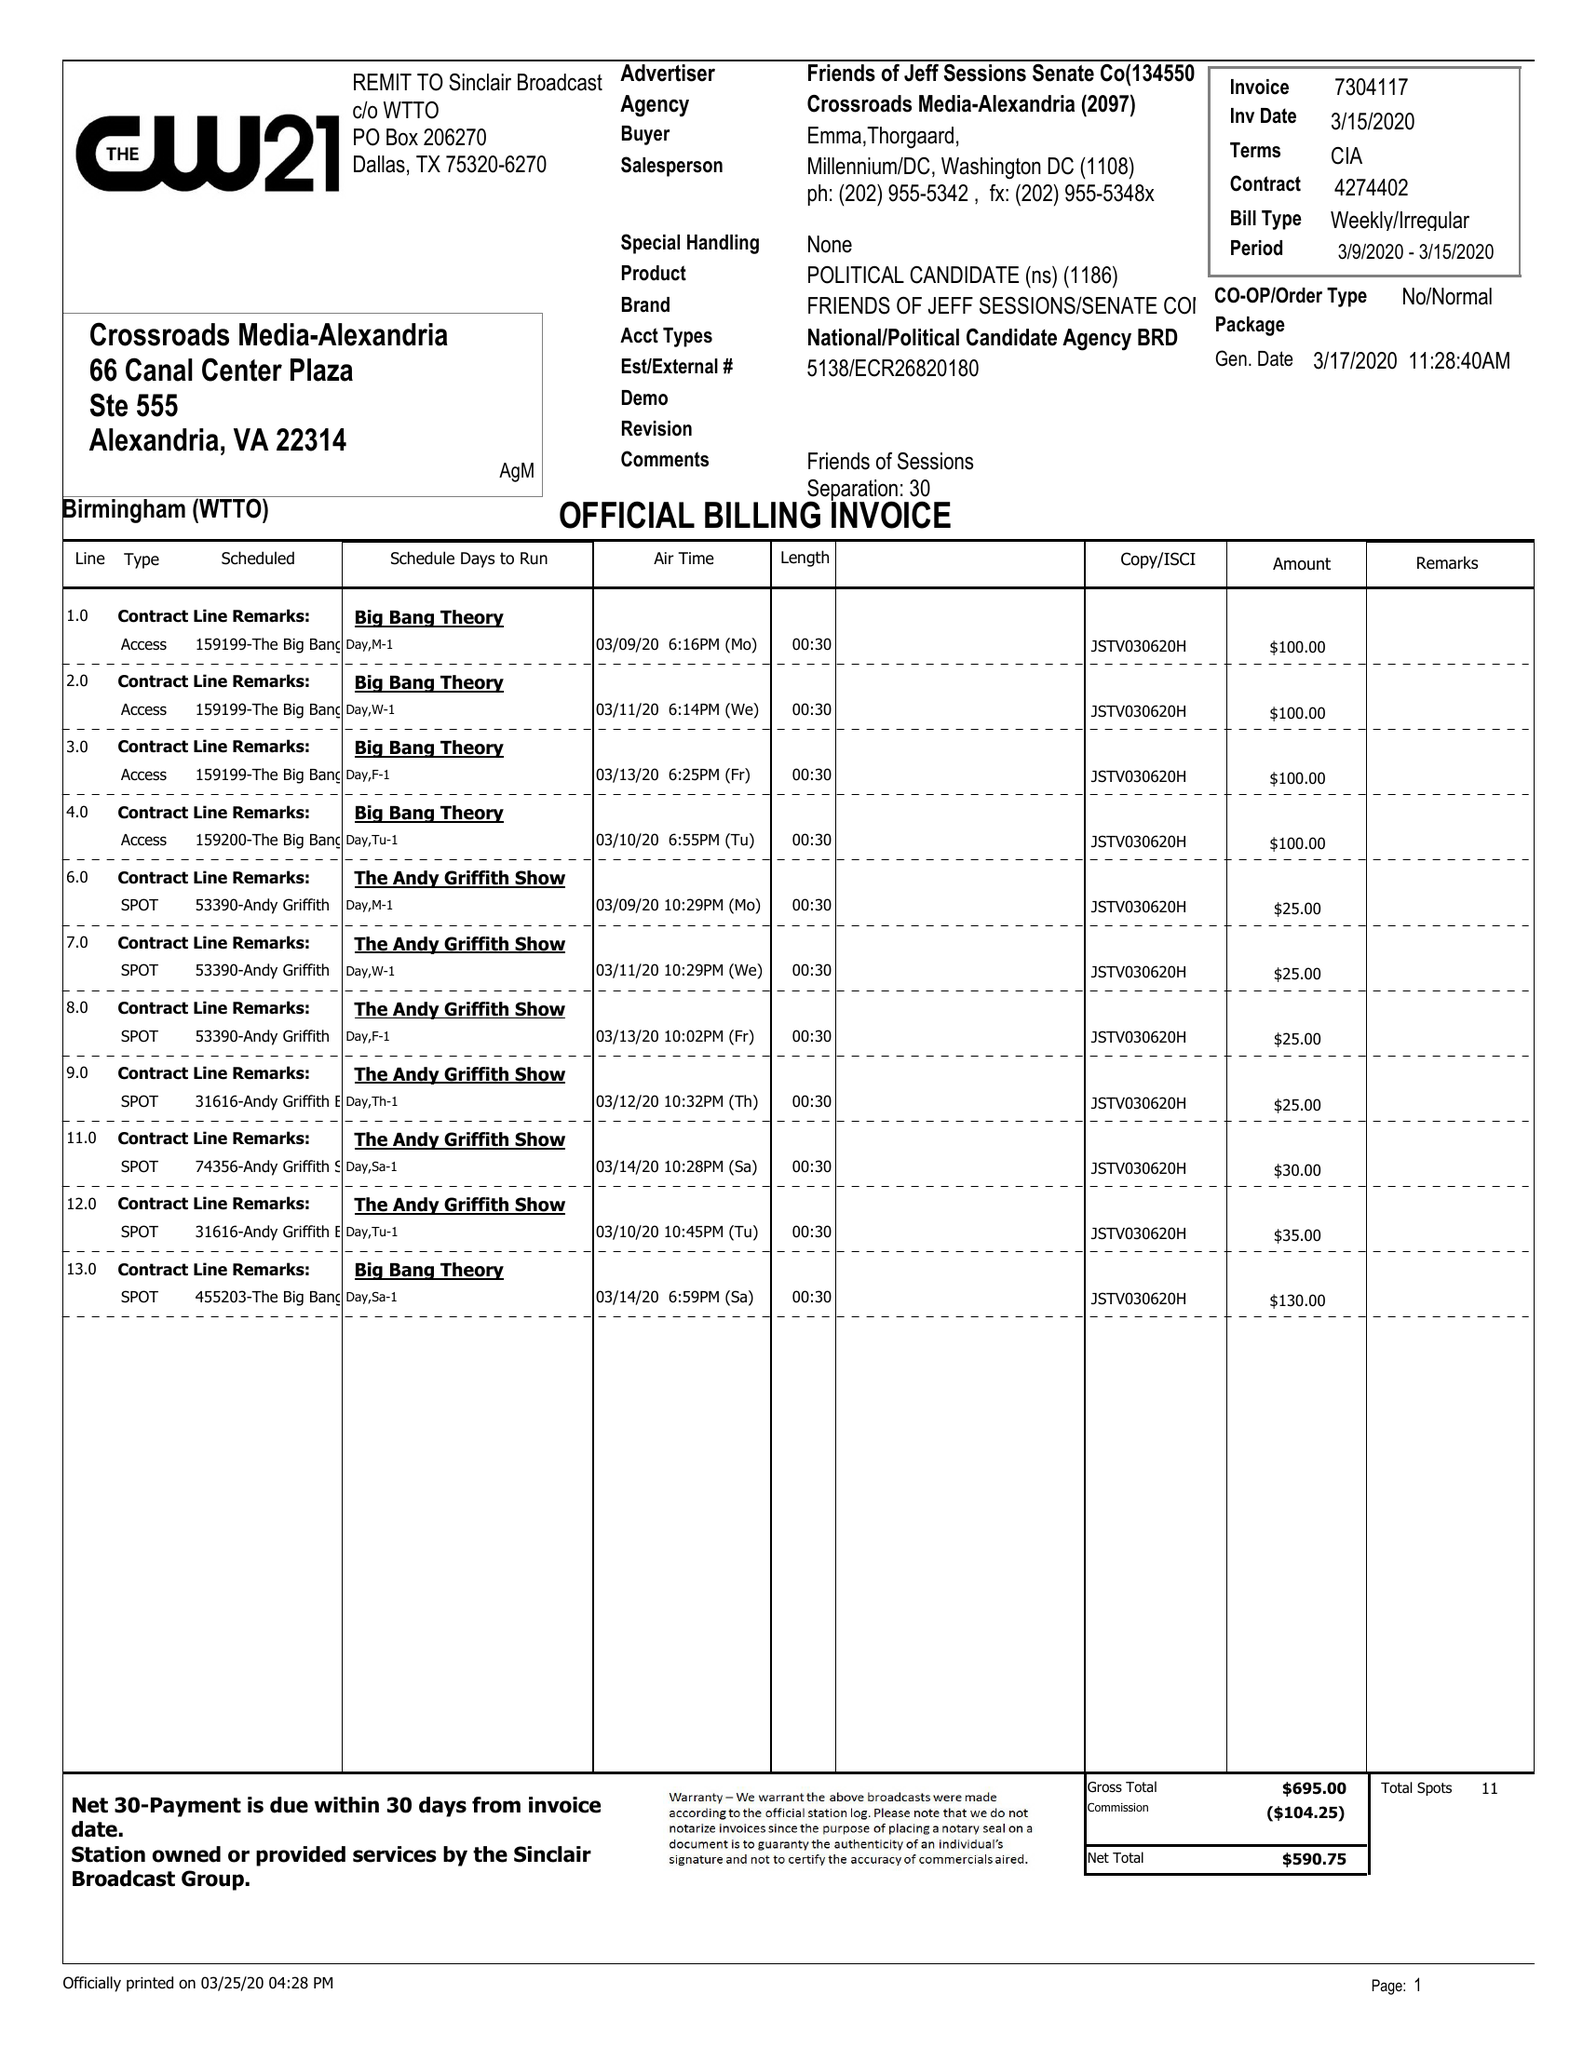What is the value for the flight_to?
Answer the question using a single word or phrase. 03/15/20 